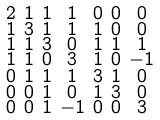<formula> <loc_0><loc_0><loc_500><loc_500>\begin{smallmatrix} 2 & 1 & 1 & 1 & 0 & 0 & 0 \\ 1 & 3 & 1 & 1 & 1 & 0 & 0 \\ 1 & 1 & 3 & 0 & 1 & 1 & 1 \\ 1 & 1 & 0 & 3 & 1 & 0 & - 1 \\ 0 & 1 & 1 & 1 & 3 & 1 & 0 \\ 0 & 0 & 1 & 0 & 1 & 3 & 0 \\ 0 & 0 & 1 & - 1 & 0 & 0 & 3 \end{smallmatrix}</formula> 